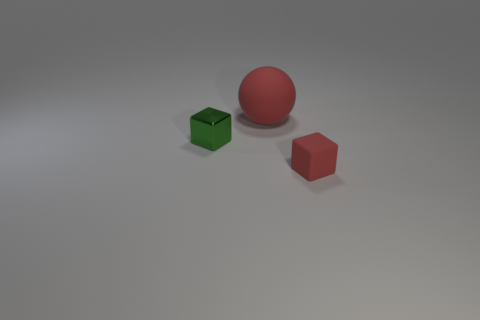Add 1 large red objects. How many objects exist? 4 Subtract all balls. How many objects are left? 2 Add 2 tiny green metallic things. How many tiny green metallic things exist? 3 Subtract 0 gray cylinders. How many objects are left? 3 Subtract all tiny red balls. Subtract all green shiny blocks. How many objects are left? 2 Add 2 green metallic things. How many green metallic things are left? 3 